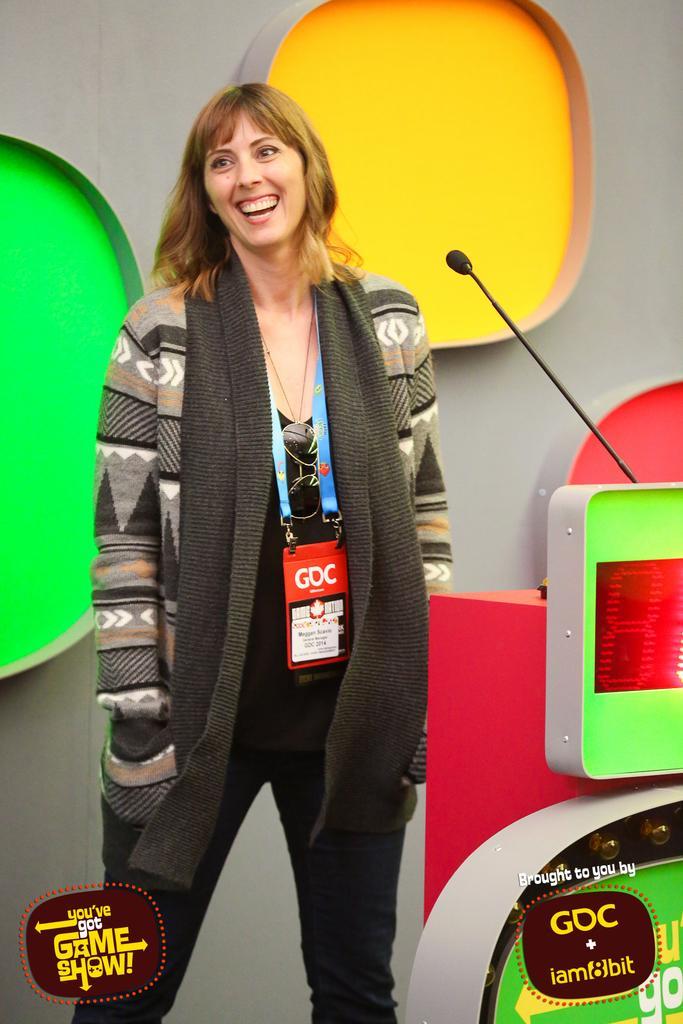Describe this image in one or two sentences. In this image there is a woman standing with a smile on her face, in front of her there is a mic on the table and there are a few boards with some text are attached to the table. At the bottom of the image there is some text. In the background there is a metal sheet on which there are colorful blocks. 